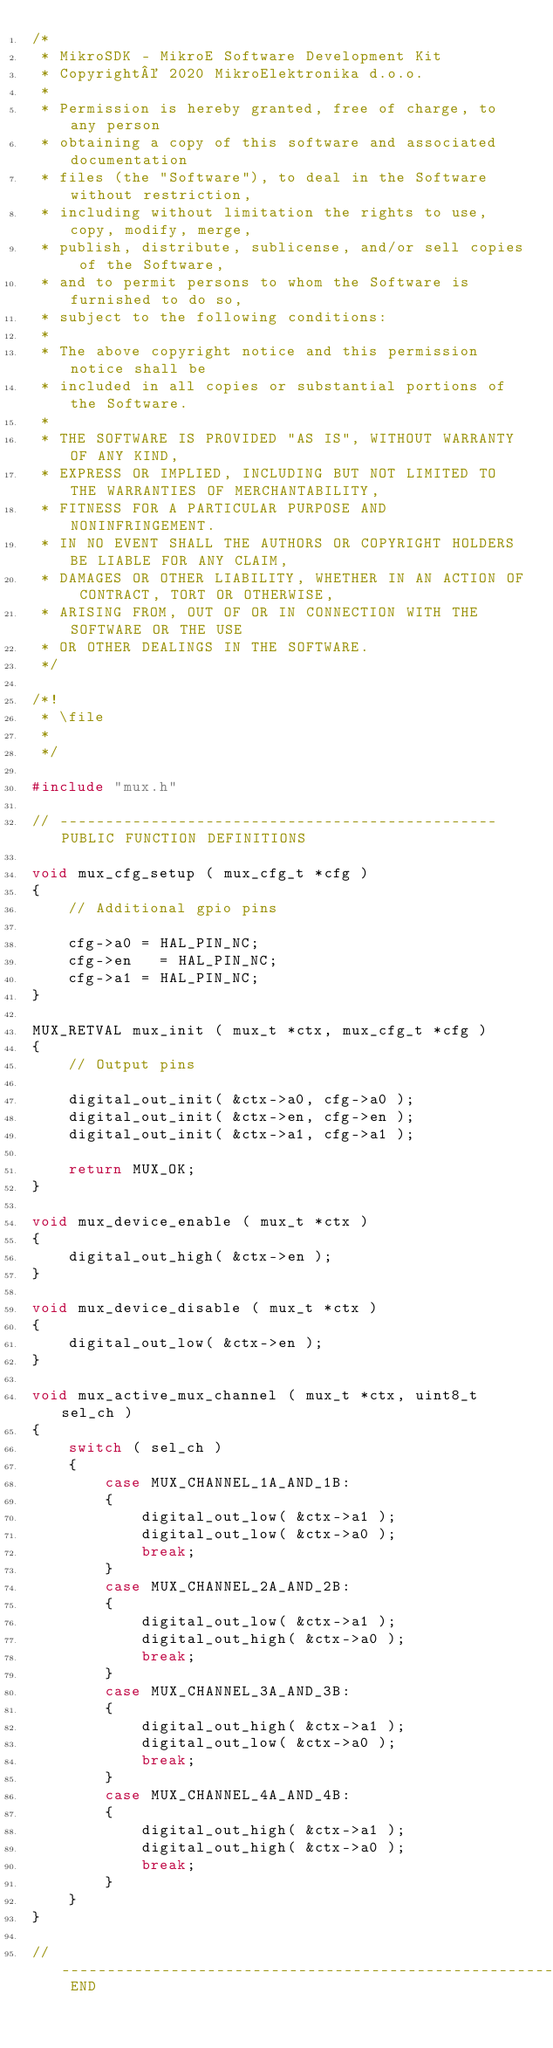<code> <loc_0><loc_0><loc_500><loc_500><_C_>/*
 * MikroSDK - MikroE Software Development Kit
 * Copyright© 2020 MikroElektronika d.o.o.
 * 
 * Permission is hereby granted, free of charge, to any person 
 * obtaining a copy of this software and associated documentation 
 * files (the "Software"), to deal in the Software without restriction, 
 * including without limitation the rights to use, copy, modify, merge, 
 * publish, distribute, sublicense, and/or sell copies of the Software, 
 * and to permit persons to whom the Software is furnished to do so, 
 * subject to the following conditions:
 * 
 * The above copyright notice and this permission notice shall be 
 * included in all copies or substantial portions of the Software.
 * 
 * THE SOFTWARE IS PROVIDED "AS IS", WITHOUT WARRANTY OF ANY KIND, 
 * EXPRESS OR IMPLIED, INCLUDING BUT NOT LIMITED TO THE WARRANTIES OF MERCHANTABILITY, 
 * FITNESS FOR A PARTICULAR PURPOSE AND NONINFRINGEMENT. 
 * IN NO EVENT SHALL THE AUTHORS OR COPYRIGHT HOLDERS BE LIABLE FOR ANY CLAIM,
 * DAMAGES OR OTHER LIABILITY, WHETHER IN AN ACTION OF CONTRACT, TORT OR OTHERWISE, 
 * ARISING FROM, OUT OF OR IN CONNECTION WITH THE SOFTWARE OR THE USE 
 * OR OTHER DEALINGS IN THE SOFTWARE. 
 */

/*!
 * \file
 *
 */

#include "mux.h"

// ------------------------------------------------ PUBLIC FUNCTION DEFINITIONS

void mux_cfg_setup ( mux_cfg_t *cfg )
{
    // Additional gpio pins

    cfg->a0 = HAL_PIN_NC;
    cfg->en   = HAL_PIN_NC;
    cfg->a1 = HAL_PIN_NC;
}

MUX_RETVAL mux_init ( mux_t *ctx, mux_cfg_t *cfg )
{
    // Output pins 

    digital_out_init( &ctx->a0, cfg->a0 );
    digital_out_init( &ctx->en, cfg->en );
    digital_out_init( &ctx->a1, cfg->a1 );

    return MUX_OK;
}

void mux_device_enable ( mux_t *ctx )
{
    digital_out_high( &ctx->en );
}

void mux_device_disable ( mux_t *ctx )
{
    digital_out_low( &ctx->en );
}

void mux_active_mux_channel ( mux_t *ctx, uint8_t sel_ch )
{
    switch ( sel_ch )
    {
        case MUX_CHANNEL_1A_AND_1B:
        {
            digital_out_low( &ctx->a1 );
            digital_out_low( &ctx->a0 );
            break;
        }
        case MUX_CHANNEL_2A_AND_2B:
        {
            digital_out_low( &ctx->a1 );
            digital_out_high( &ctx->a0 );
            break;
        }
        case MUX_CHANNEL_3A_AND_3B:
        {
            digital_out_high( &ctx->a1 );
            digital_out_low( &ctx->a0 );
            break;
        }
        case MUX_CHANNEL_4A_AND_4B:
        {
            digital_out_high( &ctx->a1 );
            digital_out_high( &ctx->a0 );
            break;
        }
    }
}

// ------------------------------------------------------------------------- END

</code> 